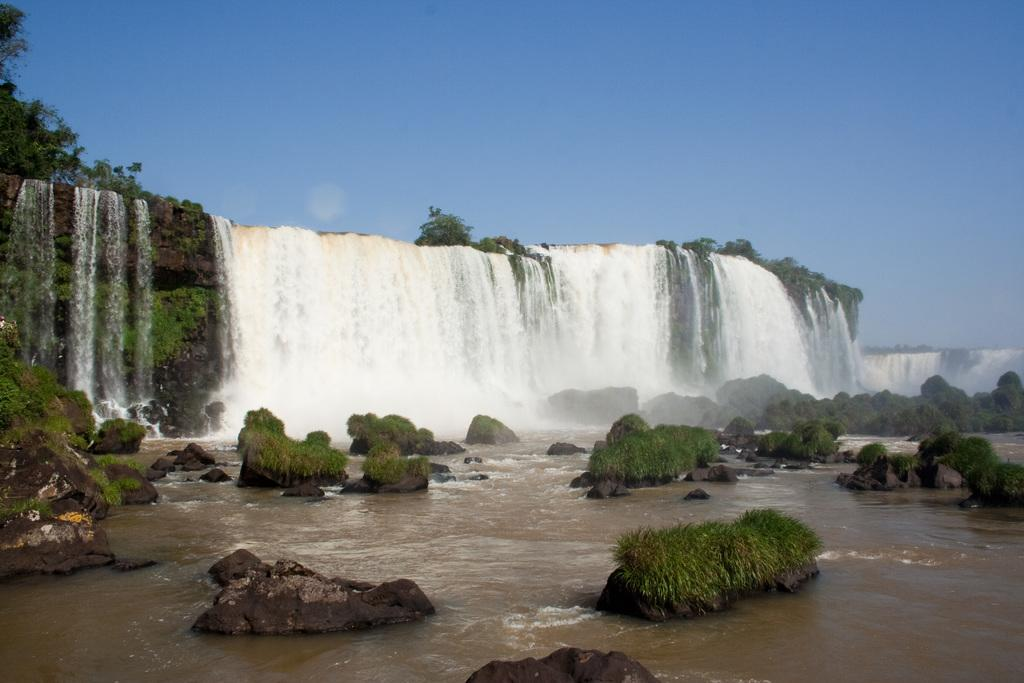What natural feature is the main subject of the image? There is a waterfall in the image. What is located below the waterfall? There is a water surface below the waterfall. What can be seen around the waterfall and water surface? There are rocks around the waterfall and water surface. What type of vegetation is present on the rocks? There is grass on the rocks. What type of pen can be seen rolling on the grass in the image? There is no pen present in the image; it features a waterfall, water surface, rocks, and grass. 